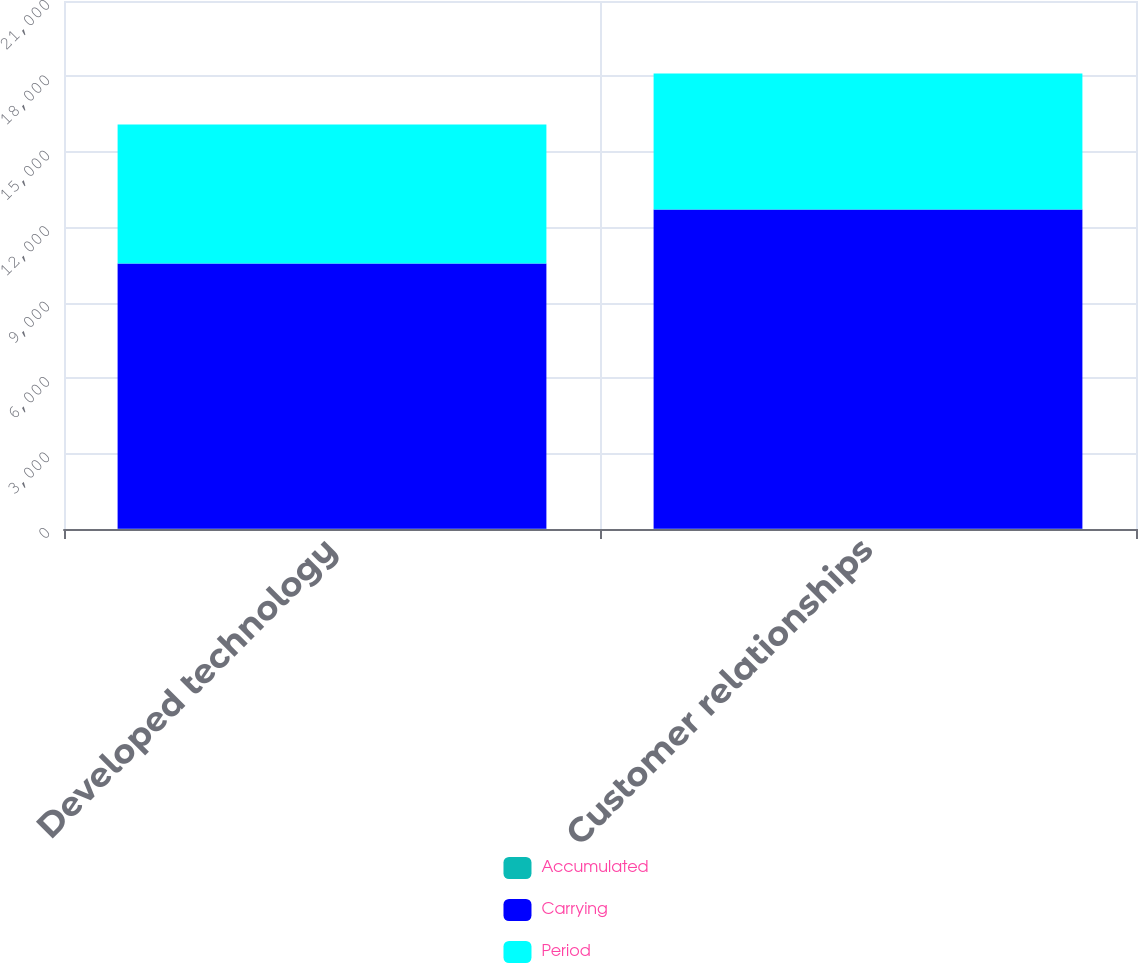Convert chart. <chart><loc_0><loc_0><loc_500><loc_500><stacked_bar_chart><ecel><fcel>Developed technology<fcel>Customer relationships<nl><fcel>Accumulated<fcel>10<fcel>10<nl><fcel>Carrying<fcel>10550<fcel>12700<nl><fcel>Period<fcel>5525<fcel>5408<nl></chart> 